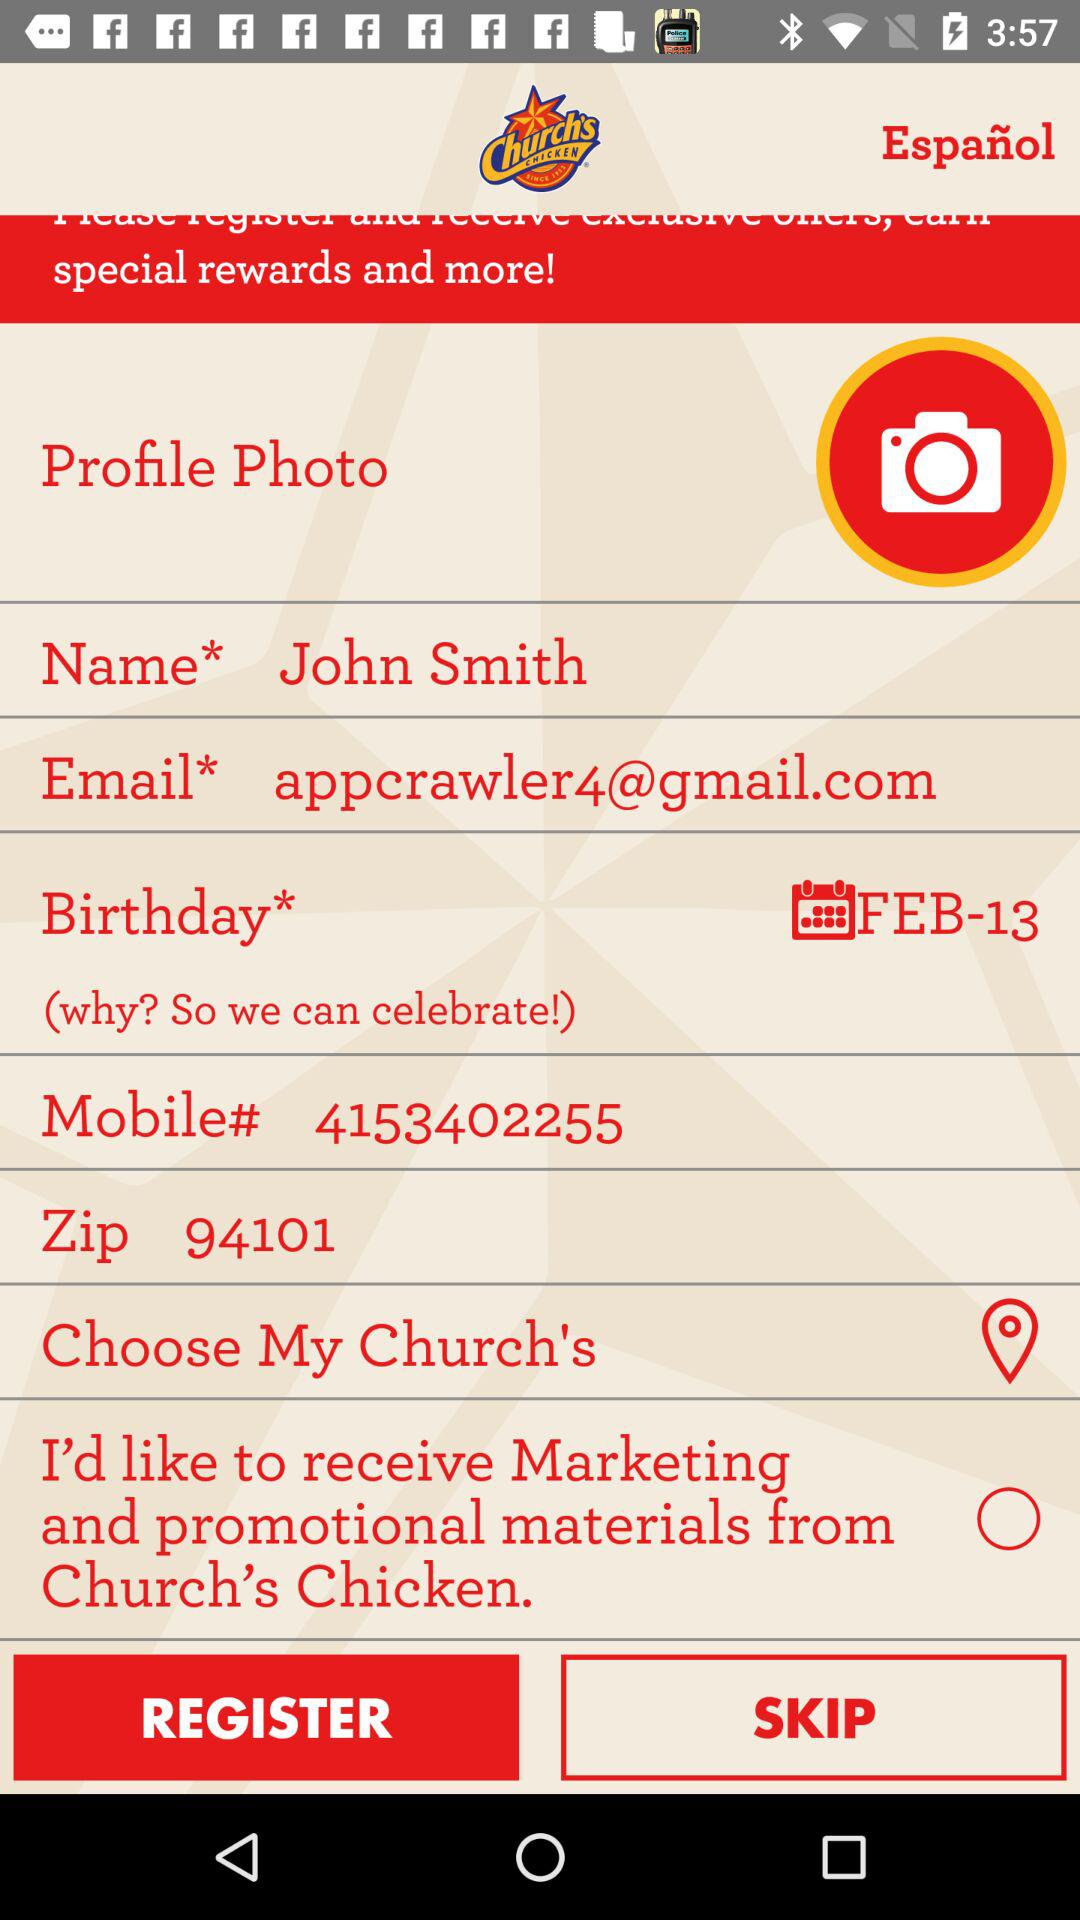When is the birthday? The birthday is on February 13. 